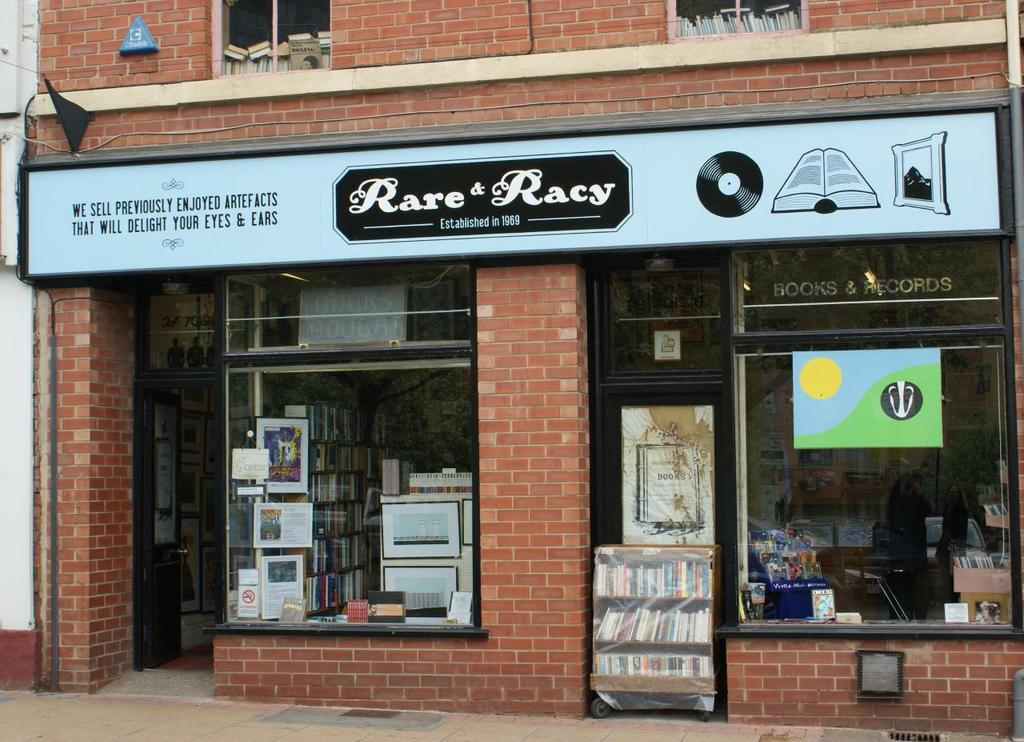<image>
Write a terse but informative summary of the picture. The Rare Racy book store was established in 1969. 